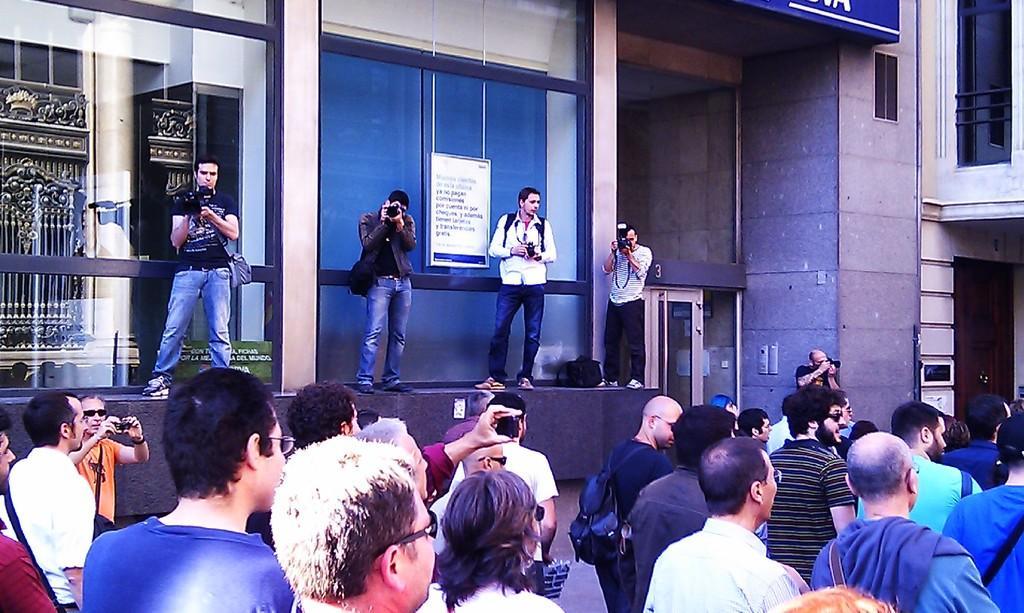Please provide a concise description of this image. Bottom of the image few people are standing. In the middle of the image few people are standing and holding cameras. Behind them there is a wall. 